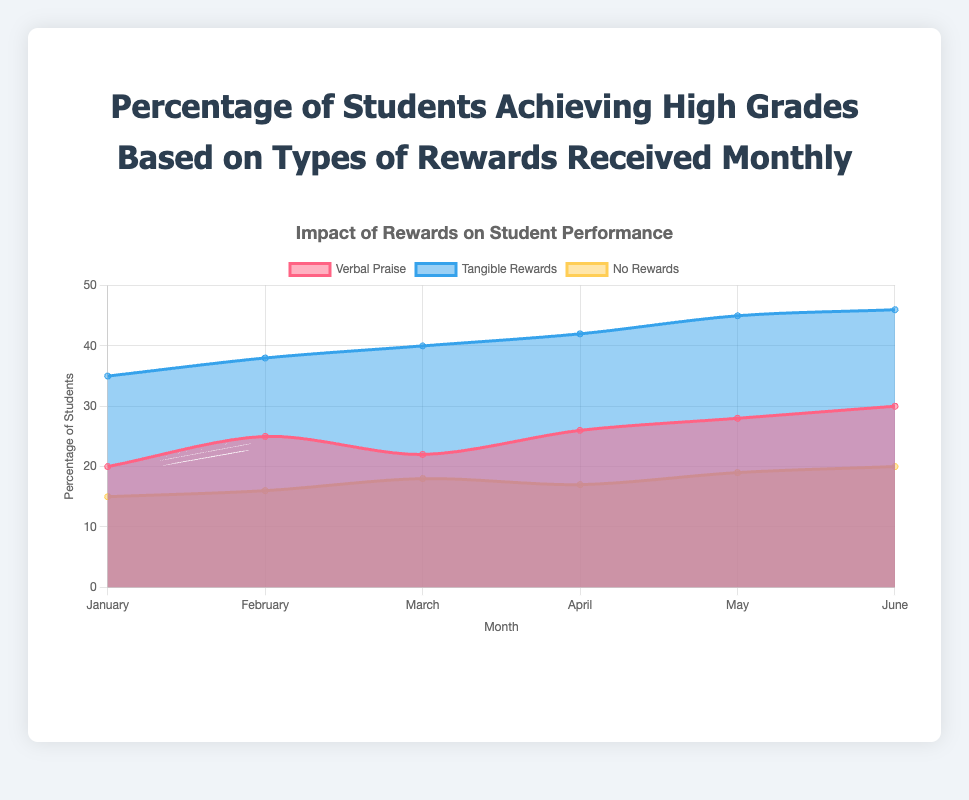What is the title of the chart? The title of the chart is located at the top and provides an overview of what the visual representation is about. Reading the title directly gives us "Percentage of Students Achieving High Grades Based on Types of Rewards Received Monthly".
Answer: Percentage of Students Achieving High Grades Based on Types of Rewards Received Monthly In which month did the highest percentage of students achieve high grades with tangible rewards? By looking at the data points for "Tangible Rewards" across all months, the highest value is seen in June with 46%.
Answer: June What is the percentage increase in students achieving high grades with verbal praise from January to June? To find the percentage increase, subtract the January value from the June value and divide it by the January value, then multiply by 100: ((30 - 20) / 20) * 100 = 50%.
Answer: 50% Which type of reward consistently had the lowest percentage of students achieving high grades each month? By comparing all three types of rewards month by month, "No Rewards" consistently has the lowest percentage across all months.
Answer: No Rewards What was the average percentage of students achieving high grades with no rewards over the six months? Summing up the numbers for "No Rewards" (15 + 16 + 18 + 17 + 19 + 20) gives 105. Dividing by six months gives the average as 105 / 6 = 17.5%.
Answer: 17.5% Compare the percentage of students achieving high grades with no rewards in March to those with tangible rewards in the same month. In March, "No Rewards" is at 18% and "Tangible Rewards" is at 40%. Comparing these, tangible rewards are much higher.
Answer: Tangible Rewards are higher Which month showed the greatest difference between students achieving high grades with verbal praise and those with no rewards? Calculate the difference for each month: January (20-15=5), February (25-16=9), March (22-18=4), April (26-17=9), May (28-19=9), June (30-20=10). The greatest difference is in June.
Answer: June How does the trend in the percentage of students achieving high grades with tangible rewards change over the months? Observing the trend line for "Tangible Rewards", there is a steady increase from January (35%) to June (46%).
Answer: Steady increase What is the median percentage of students achieving high grades with verbal praise across the six months? The percentages for verbal praise are 20, 25, 22, 26, 28, 30. Sorting these values gives 20, 22, 25, 26, 28, 30. The median is the average of the middle two numbers (25 and 26), so (25 + 26) / 2 = 25.5%.
Answer: 25.5% Which type of reward showed the least fluctuation in the percentage of students achieving high grades over six months? To identify fluctuation, compare the range (max-min) for each type of reward: Verbal Praise (30-20=10), Tangible Rewards (46-35=11), No Rewards (20-15=5). "No Rewards" had the least fluctuation with a range of 5%.
Answer: No Rewards 